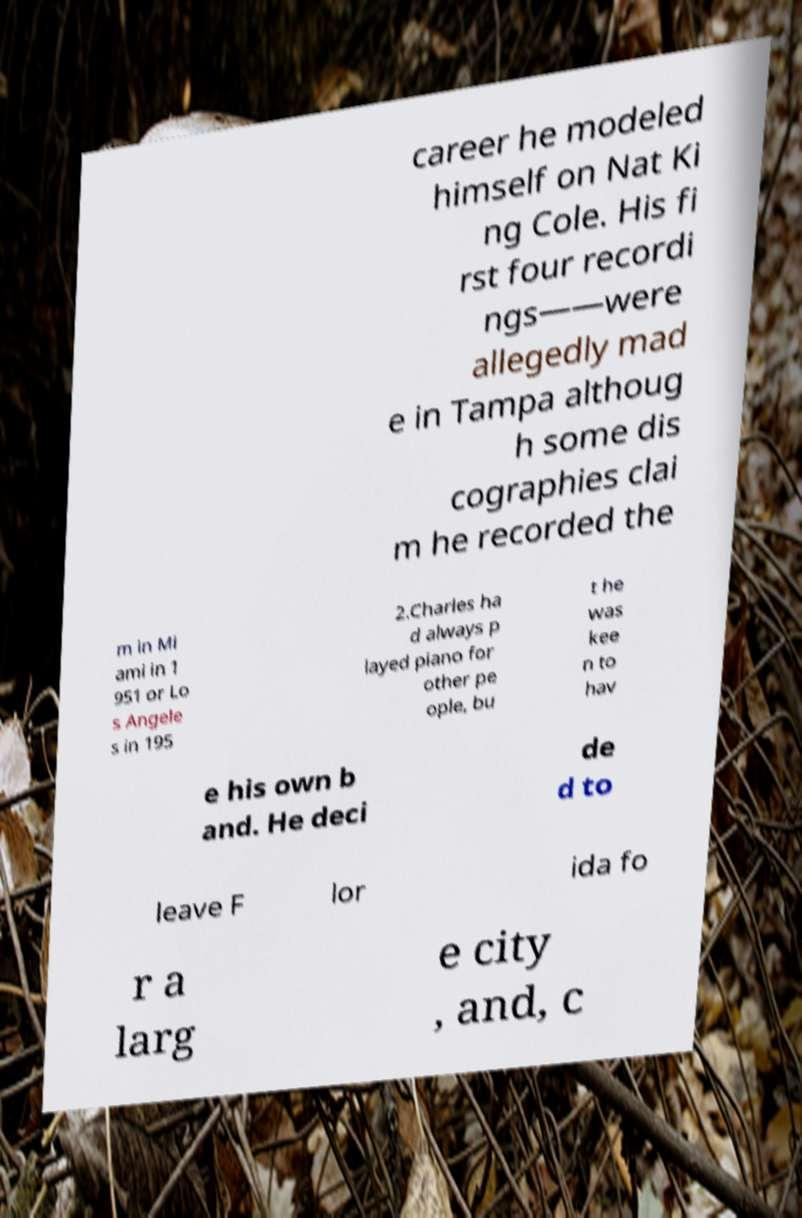I need the written content from this picture converted into text. Can you do that? career he modeled himself on Nat Ki ng Cole. His fi rst four recordi ngs——were allegedly mad e in Tampa althoug h some dis cographies clai m he recorded the m in Mi ami in 1 951 or Lo s Angele s in 195 2.Charles ha d always p layed piano for other pe ople, bu t he was kee n to hav e his own b and. He deci de d to leave F lor ida fo r a larg e city , and, c 